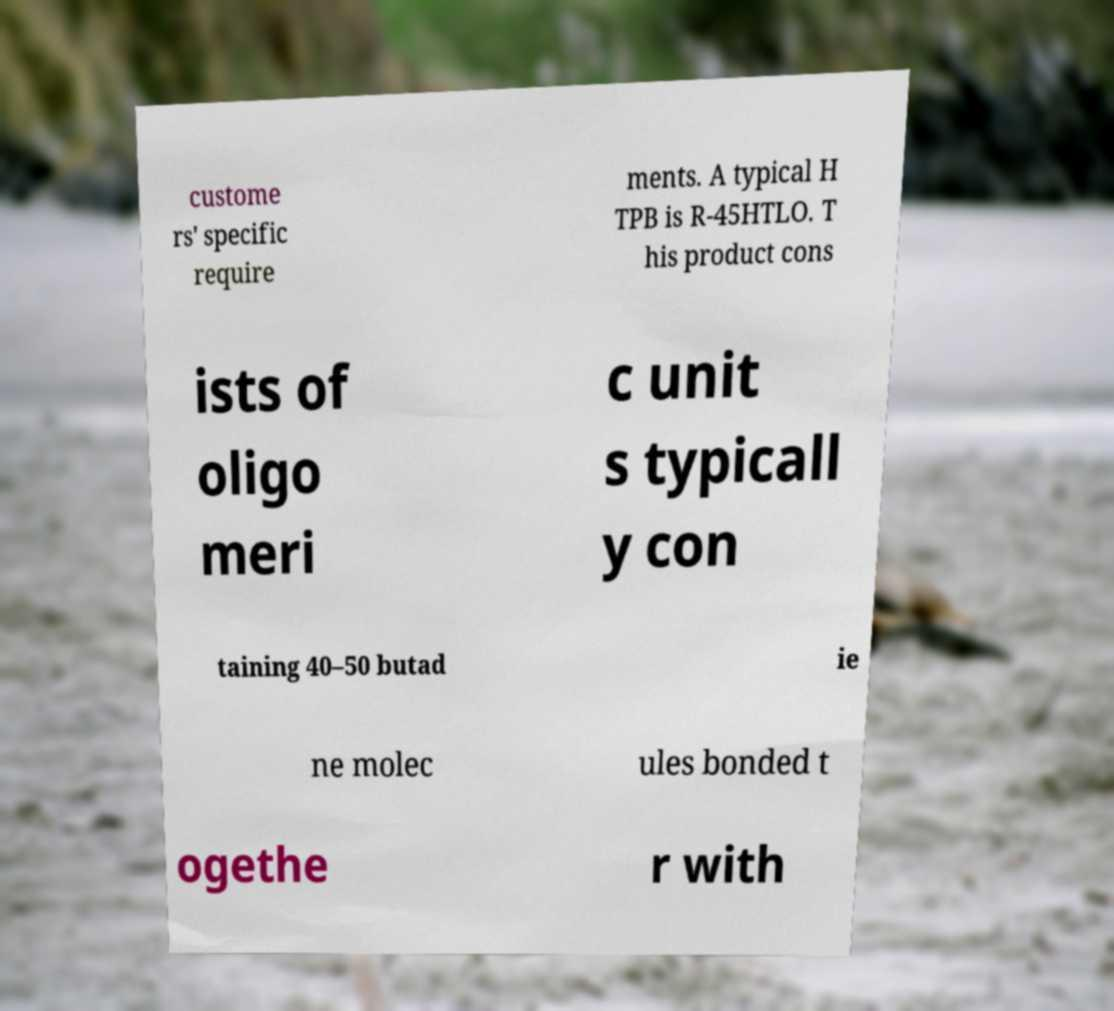Could you extract and type out the text from this image? custome rs' specific require ments. A typical H TPB is R-45HTLO. T his product cons ists of oligo meri c unit s typicall y con taining 40–50 butad ie ne molec ules bonded t ogethe r with 